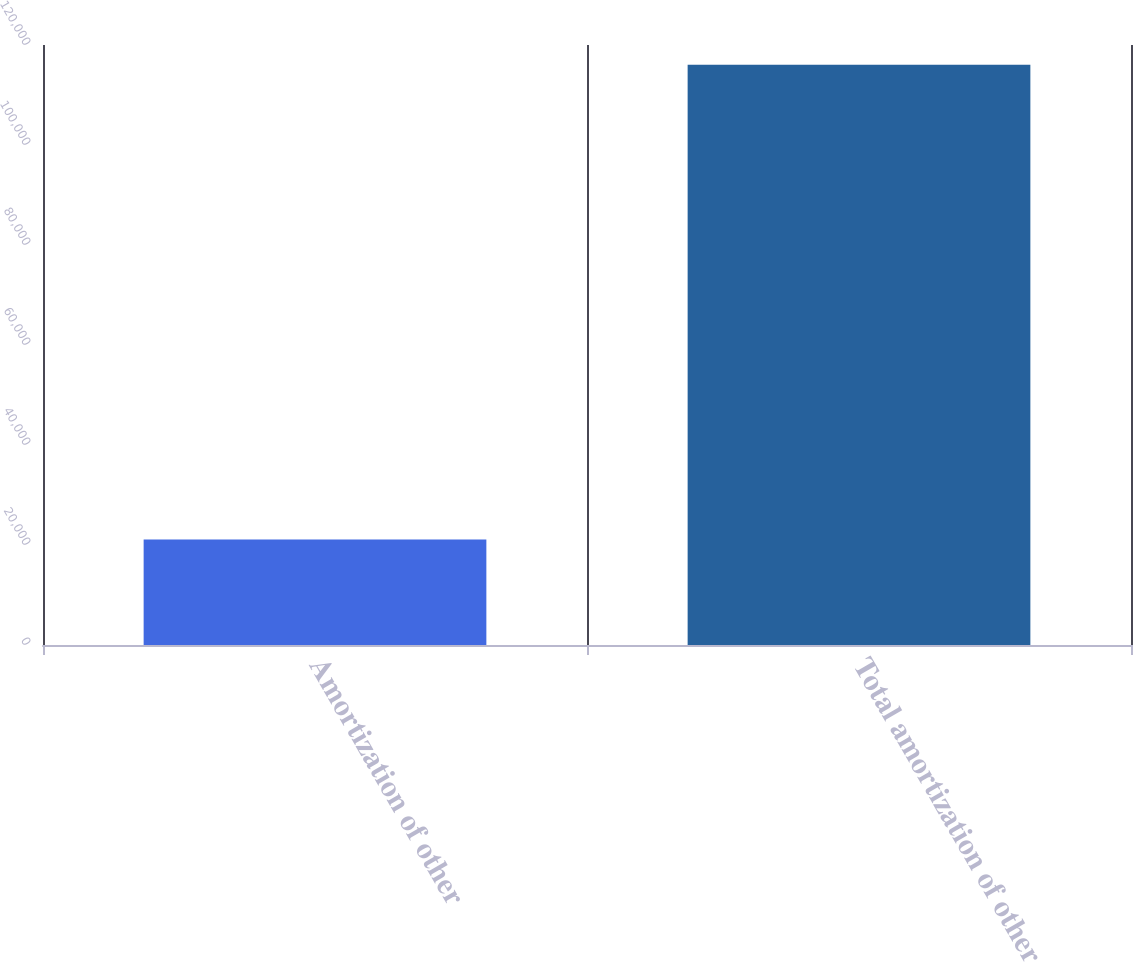Convert chart. <chart><loc_0><loc_0><loc_500><loc_500><bar_chart><fcel>Amortization of other<fcel>Total amortization of other<nl><fcel>21091<fcel>116064<nl></chart> 